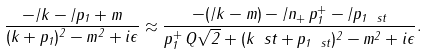Convert formula to latex. <formula><loc_0><loc_0><loc_500><loc_500>\frac { - \slash k - \slash p _ { 1 } + m } { ( k + p _ { 1 } ) ^ { 2 } - m ^ { 2 } + i \epsilon } \approx \frac { - ( \slash k - m ) - \slash n _ { + } \, p _ { 1 } ^ { + } - \slash p _ { 1 \ s t } } { p _ { 1 } ^ { + } \, Q \sqrt { 2 } + ( k _ { \ } s t + p _ { 1 \ s t } ) ^ { 2 } - m ^ { 2 } + i \epsilon } .</formula> 